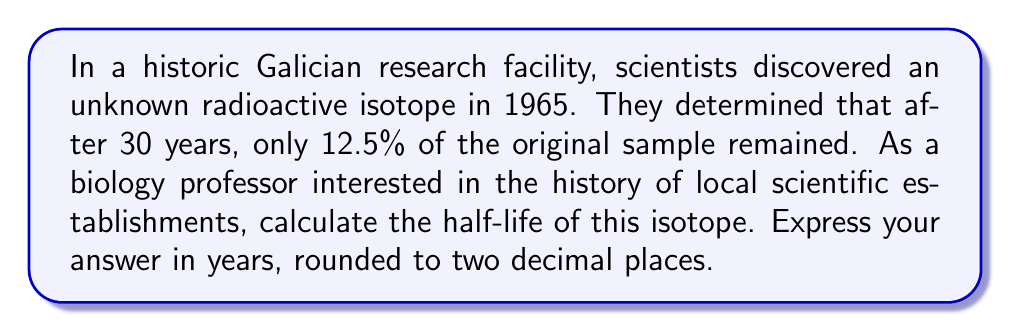Teach me how to tackle this problem. To solve this problem, we'll use the exponential decay formula and the concept of half-life:

1) The exponential decay formula is:
   $$ A(t) = A_0 \cdot (0.5)^{t/t_{1/2}} $$
   Where:
   $A(t)$ is the amount remaining after time $t$
   $A_0$ is the initial amount
   $t$ is the time elapsed
   $t_{1/2}$ is the half-life

2) We know that after 30 years, 12.5% (or 0.125) of the original sample remained. Let's substitute these values:
   $$ 0.125 = 1 \cdot (0.5)^{30/t_{1/2}} $$

3) Take the natural logarithm of both sides:
   $$ \ln(0.125) = \ln((0.5)^{30/t_{1/2}}) $$

4) Use the logarithm property $\ln(a^b) = b\ln(a)$:
   $$ \ln(0.125) = \frac{30}{t_{1/2}} \cdot \ln(0.5) $$

5) Solve for $t_{1/2}$:
   $$ t_{1/2} = \frac{30 \cdot \ln(0.5)}{\ln(0.125)} $$

6) Calculate:
   $$ t_{1/2} = \frac{30 \cdot (-0.6931)}{-2.0794} \approx 10.0206 \text{ years} $$

7) Round to two decimal places: 10.02 years
Answer: The half-life of the radioactive isotope is 10.02 years. 